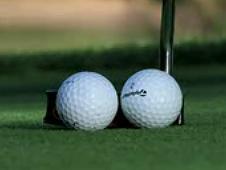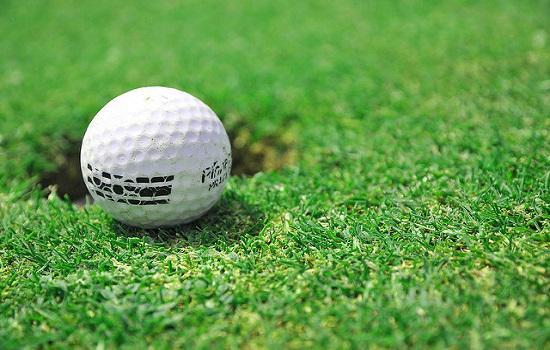The first image is the image on the left, the second image is the image on the right. For the images displayed, is the sentence "At least one image shows a golf ball on top of a tee." factually correct? Answer yes or no. No. The first image is the image on the left, the second image is the image on the right. Considering the images on both sides, is "A golf club is behind at least one golf ball." valid? Answer yes or no. Yes. 